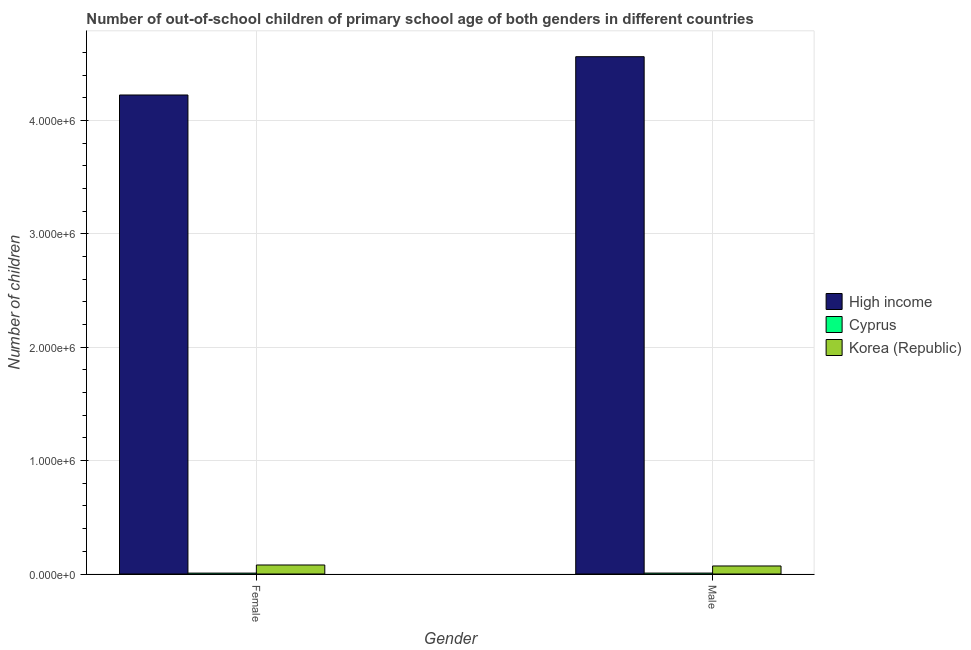How many different coloured bars are there?
Provide a succinct answer. 3. How many bars are there on the 2nd tick from the left?
Provide a succinct answer. 3. How many bars are there on the 2nd tick from the right?
Provide a short and direct response. 3. What is the label of the 2nd group of bars from the left?
Provide a succinct answer. Male. What is the number of female out-of-school students in Cyprus?
Offer a very short reply. 7978. Across all countries, what is the maximum number of female out-of-school students?
Offer a terse response. 4.23e+06. Across all countries, what is the minimum number of female out-of-school students?
Give a very brief answer. 7978. In which country was the number of male out-of-school students minimum?
Keep it short and to the point. Cyprus. What is the total number of male out-of-school students in the graph?
Your answer should be very brief. 4.64e+06. What is the difference between the number of female out-of-school students in Korea (Republic) and that in High income?
Your response must be concise. -4.15e+06. What is the difference between the number of female out-of-school students in Cyprus and the number of male out-of-school students in Korea (Republic)?
Provide a short and direct response. -6.28e+04. What is the average number of male out-of-school students per country?
Make the answer very short. 1.55e+06. What is the difference between the number of female out-of-school students and number of male out-of-school students in High income?
Make the answer very short. -3.38e+05. In how many countries, is the number of female out-of-school students greater than 800000 ?
Give a very brief answer. 1. What is the ratio of the number of female out-of-school students in Korea (Republic) to that in Cyprus?
Provide a short and direct response. 9.96. Is the number of female out-of-school students in Korea (Republic) less than that in Cyprus?
Keep it short and to the point. No. What does the 3rd bar from the right in Female represents?
Give a very brief answer. High income. Does the graph contain any zero values?
Your answer should be compact. No. Where does the legend appear in the graph?
Provide a succinct answer. Center right. How many legend labels are there?
Give a very brief answer. 3. What is the title of the graph?
Offer a terse response. Number of out-of-school children of primary school age of both genders in different countries. What is the label or title of the Y-axis?
Keep it short and to the point. Number of children. What is the Number of children in High income in Female?
Offer a very short reply. 4.23e+06. What is the Number of children in Cyprus in Female?
Your answer should be very brief. 7978. What is the Number of children in Korea (Republic) in Female?
Offer a very short reply. 7.95e+04. What is the Number of children in High income in Male?
Your answer should be compact. 4.56e+06. What is the Number of children of Cyprus in Male?
Provide a succinct answer. 8295. What is the Number of children of Korea (Republic) in Male?
Provide a short and direct response. 7.08e+04. Across all Gender, what is the maximum Number of children of High income?
Provide a succinct answer. 4.56e+06. Across all Gender, what is the maximum Number of children of Cyprus?
Provide a succinct answer. 8295. Across all Gender, what is the maximum Number of children in Korea (Republic)?
Give a very brief answer. 7.95e+04. Across all Gender, what is the minimum Number of children of High income?
Your response must be concise. 4.23e+06. Across all Gender, what is the minimum Number of children of Cyprus?
Offer a terse response. 7978. Across all Gender, what is the minimum Number of children in Korea (Republic)?
Make the answer very short. 7.08e+04. What is the total Number of children of High income in the graph?
Your response must be concise. 8.79e+06. What is the total Number of children of Cyprus in the graph?
Provide a short and direct response. 1.63e+04. What is the total Number of children in Korea (Republic) in the graph?
Offer a very short reply. 1.50e+05. What is the difference between the Number of children in High income in Female and that in Male?
Make the answer very short. -3.38e+05. What is the difference between the Number of children in Cyprus in Female and that in Male?
Provide a short and direct response. -317. What is the difference between the Number of children of Korea (Republic) in Female and that in Male?
Make the answer very short. 8677. What is the difference between the Number of children in High income in Female and the Number of children in Cyprus in Male?
Your answer should be very brief. 4.22e+06. What is the difference between the Number of children in High income in Female and the Number of children in Korea (Republic) in Male?
Your answer should be compact. 4.16e+06. What is the difference between the Number of children in Cyprus in Female and the Number of children in Korea (Republic) in Male?
Provide a succinct answer. -6.28e+04. What is the average Number of children of High income per Gender?
Your response must be concise. 4.40e+06. What is the average Number of children in Cyprus per Gender?
Offer a very short reply. 8136.5. What is the average Number of children in Korea (Republic) per Gender?
Provide a short and direct response. 7.51e+04. What is the difference between the Number of children in High income and Number of children in Cyprus in Female?
Offer a terse response. 4.22e+06. What is the difference between the Number of children in High income and Number of children in Korea (Republic) in Female?
Give a very brief answer. 4.15e+06. What is the difference between the Number of children of Cyprus and Number of children of Korea (Republic) in Female?
Provide a short and direct response. -7.15e+04. What is the difference between the Number of children in High income and Number of children in Cyprus in Male?
Keep it short and to the point. 4.56e+06. What is the difference between the Number of children of High income and Number of children of Korea (Republic) in Male?
Your response must be concise. 4.49e+06. What is the difference between the Number of children of Cyprus and Number of children of Korea (Republic) in Male?
Give a very brief answer. -6.25e+04. What is the ratio of the Number of children in High income in Female to that in Male?
Ensure brevity in your answer.  0.93. What is the ratio of the Number of children of Cyprus in Female to that in Male?
Give a very brief answer. 0.96. What is the ratio of the Number of children in Korea (Republic) in Female to that in Male?
Give a very brief answer. 1.12. What is the difference between the highest and the second highest Number of children in High income?
Your answer should be very brief. 3.38e+05. What is the difference between the highest and the second highest Number of children in Cyprus?
Give a very brief answer. 317. What is the difference between the highest and the second highest Number of children in Korea (Republic)?
Provide a succinct answer. 8677. What is the difference between the highest and the lowest Number of children of High income?
Provide a succinct answer. 3.38e+05. What is the difference between the highest and the lowest Number of children in Cyprus?
Your answer should be compact. 317. What is the difference between the highest and the lowest Number of children in Korea (Republic)?
Give a very brief answer. 8677. 